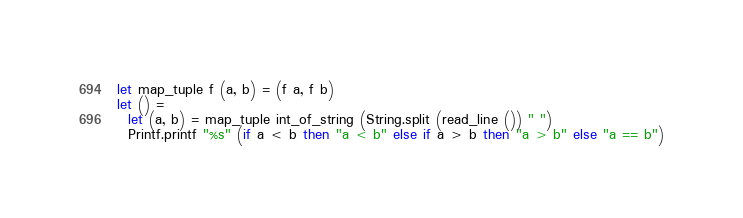Convert code to text. <code><loc_0><loc_0><loc_500><loc_500><_OCaml_>let map_tuple f (a, b) = (f a, f b)
let () =
  let (a, b) = map_tuple int_of_string (String.split (read_line ()) " ")
  Printf.printf "%s" (if a < b then "a < b" else if a > b then "a > b" else "a == b")</code> 